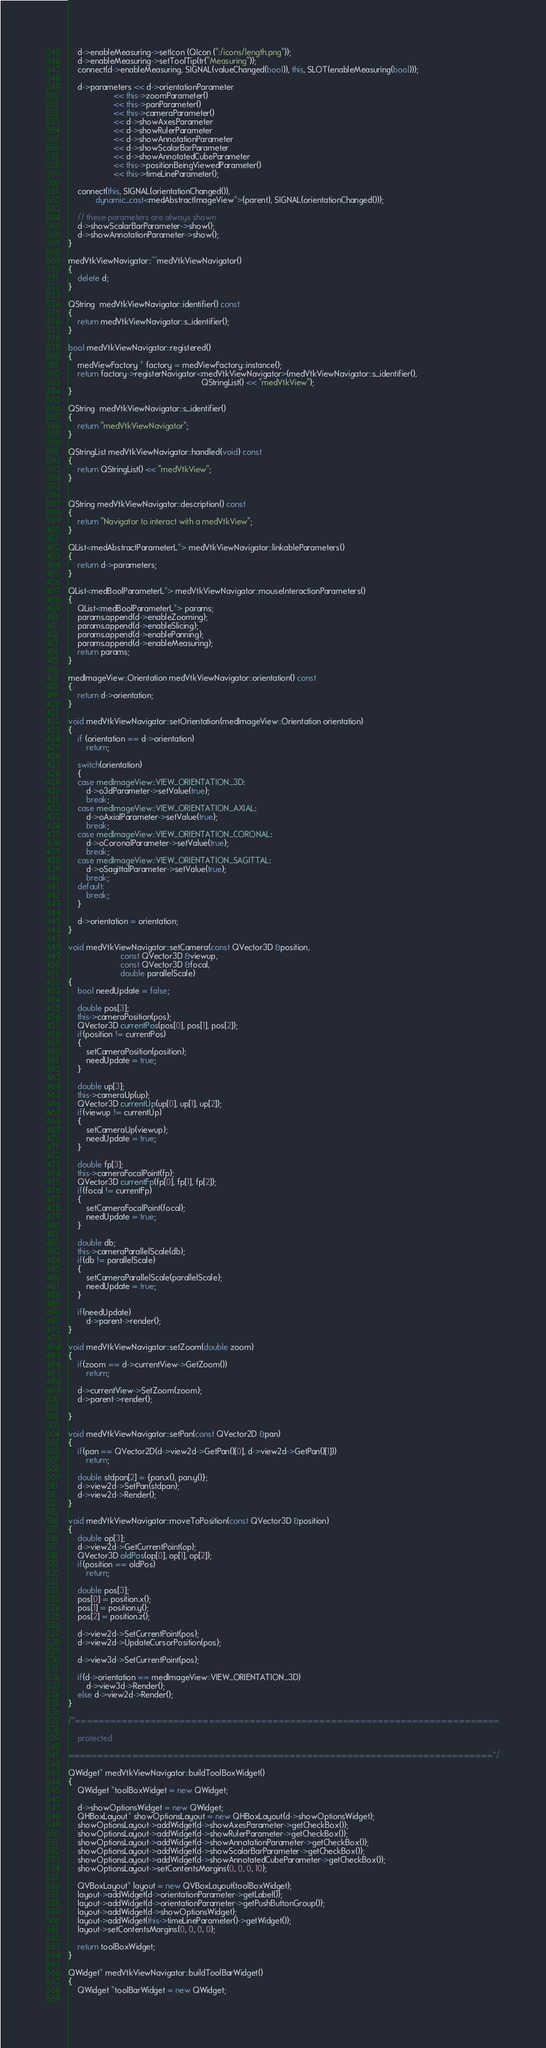<code> <loc_0><loc_0><loc_500><loc_500><_C++_>    d->enableMeasuring->setIcon (QIcon (":/icons/length.png"));
    d->enableMeasuring->setToolTip(tr("Measuring"));
    connect(d->enableMeasuring, SIGNAL(valueChanged(bool)), this, SLOT(enableMeasuring(bool)));

    d->parameters << d->orientationParameter
                    << this->zoomParameter()
                    << this->panParameter()
                    << this->cameraParameter()
                    << d->showAxesParameter
                    << d->showRulerParameter
                    << d->showAnnotationParameter
                    << d->showScalarBarParameter
                    << d->showAnnotatedCubeParameter
                    << this->positionBeingViewedParameter()
                    << this->timeLineParameter();

    connect(this, SIGNAL(orientationChanged()),
            dynamic_cast<medAbstractImageView*>(parent), SIGNAL(orientationChanged()));

    // these parameters are always shown
    d->showScalarBarParameter->show();
    d->showAnnotationParameter->show();
}

medVtkViewNavigator::~medVtkViewNavigator()
{
    delete d;
}

QString  medVtkViewNavigator::identifier() const
{
    return medVtkViewNavigator::s_identifier();
}

bool medVtkViewNavigator::registered()
{
    medViewFactory * factory = medViewFactory::instance();
    return factory->registerNavigator<medVtkViewNavigator>(medVtkViewNavigator::s_identifier(),
                                                           QStringList() << "medVtkView");
}

QString  medVtkViewNavigator::s_identifier()
{
    return "medVtkViewNavigator";
}

QStringList medVtkViewNavigator::handled(void) const
{
    return QStringList() << "medVtkView";
}


QString medVtkViewNavigator::description() const
{
    return "Navigator to interact with a medVtkView";
}

QList<medAbstractParameterL*> medVtkViewNavigator::linkableParameters()
{
    return d->parameters;
}

QList<medBoolParameterL*> medVtkViewNavigator::mouseInteractionParameters()
{
    QList<medBoolParameterL*> params;
    params.append(d->enableZooming);
    params.append(d->enableSlicing);
    params.append(d->enablePanning);
    params.append(d->enableMeasuring);
    return params;
}

medImageView::Orientation medVtkViewNavigator::orientation() const
{
    return d->orientation;
}

void medVtkViewNavigator::setOrientation(medImageView::Orientation orientation)
{
    if (orientation == d->orientation)
        return;

    switch(orientation)
    {
    case medImageView::VIEW_ORIENTATION_3D:
        d->o3dParameter->setValue(true);
        break;
    case medImageView::VIEW_ORIENTATION_AXIAL:
        d->oAxialParameter->setValue(true);
        break;
    case medImageView::VIEW_ORIENTATION_CORONAL:
        d->oCoronalParameter->setValue(true);
        break;
    case medImageView::VIEW_ORIENTATION_SAGITTAL:
        d->oSagittalParameter->setValue(true);
        break;
    default:
        break;
    }

    d->orientation = orientation;
}

void medVtkViewNavigator::setCamera(const QVector3D &position,
                       const QVector3D &viewup,
                       const QVector3D &focal,
                       double parallelScale)
{
    bool needUpdate = false;

    double pos[3];
    this->cameraPosition(pos);
    QVector3D currentPos(pos[0], pos[1], pos[2]);
    if(position != currentPos)
    {
        setCameraPosition(position);
        needUpdate = true;
    }

    double up[3];
    this->cameraUp(up);
    QVector3D currentUp(up[0], up[1], up[2]);
    if(viewup != currentUp)
    {
        setCameraUp(viewup);
        needUpdate = true;
    }

    double fp[3];
    this->cameraFocalPoint(fp);
    QVector3D currentFp(fp[0], fp[1], fp[2]);
    if(focal != currentFp)
    {
        setCameraFocalPoint(focal);
        needUpdate = true;
    }

    double db;
    this->cameraParallelScale(db);
    if(db != parallelScale)
    {
        setCameraParallelScale(parallelScale);
        needUpdate = true;
    }

    if(needUpdate)
        d->parent->render();
}

void medVtkViewNavigator::setZoom(double zoom)
{
    if(zoom == d->currentView->GetZoom())
        return;

    d->currentView->SetZoom(zoom);
    d->parent->render();

}

void medVtkViewNavigator::setPan(const QVector2D &pan)
{
    if(pan == QVector2D(d->view2d->GetPan()[0], d->view2d->GetPan()[1]))
        return;

    double stdpan[2] = {pan.x(), pan.y()};
    d->view2d->SetPan(stdpan);
    d->view2d->Render();
}

void medVtkViewNavigator::moveToPosition(const QVector3D &position)
{
    double op[3];
    d->view2d->GetCurrentPoint(op);
    QVector3D oldPos(op[0], op[1], op[2]);
    if(position == oldPos)
        return;

    double pos[3];
    pos[0] = position.x();
    pos[1] = position.y();
    pos[2] = position.z();

    d->view2d->SetCurrentPoint(pos);
    d->view2d->UpdateCursorPosition(pos);

    d->view3d->SetCurrentPoint(pos);

    if(d->orientation == medImageView::VIEW_ORIENTATION_3D)
        d->view3d->Render();
    else d->view2d->Render();
}

/*=========================================================================

    protected

=========================================================================*/

QWidget* medVtkViewNavigator::buildToolBoxWidget()
{
    QWidget *toolBoxWidget = new QWidget;

    d->showOptionsWidget = new QWidget;
    QHBoxLayout* showOptionsLayout = new QHBoxLayout(d->showOptionsWidget);
    showOptionsLayout->addWidget(d->showAxesParameter->getCheckBox());
    showOptionsLayout->addWidget(d->showRulerParameter->getCheckBox());
    showOptionsLayout->addWidget(d->showAnnotationParameter->getCheckBox());
    showOptionsLayout->addWidget(d->showScalarBarParameter->getCheckBox());
    showOptionsLayout->addWidget(d->showAnnotatedCubeParameter->getCheckBox());
    showOptionsLayout->setContentsMargins(0, 0, 0, 10);

    QVBoxLayout* layout = new QVBoxLayout(toolBoxWidget);
    layout->addWidget(d->orientationParameter->getLabel());
    layout->addWidget(d->orientationParameter->getPushButtonGroup());
    layout->addWidget(d->showOptionsWidget);
    layout->addWidget(this->timeLineParameter()->getWidget());
    layout->setContentsMargins(0, 0, 0, 0);

    return toolBoxWidget;
}

QWidget* medVtkViewNavigator::buildToolBarWidget()
{
    QWidget *toolBarWidget = new QWidget;
    </code> 